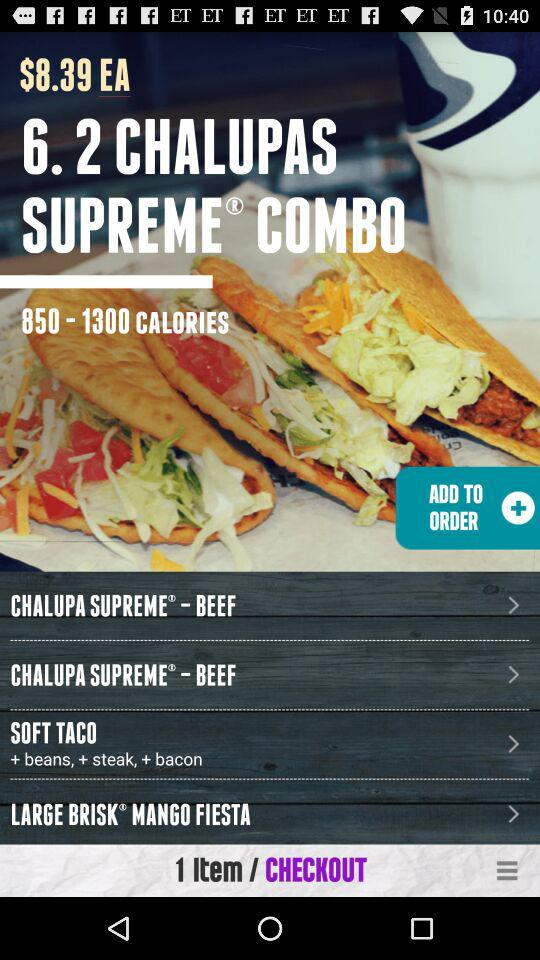How many calories are in "6. 2 CHALUPAS SUPREME COMBO"? "6. 2 CHALUPAS SUPREME COMBO" contains 850-1300 calories. 